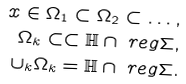<formula> <loc_0><loc_0><loc_500><loc_500>x \in \Omega _ { 1 } \subset \Omega _ { 2 } \subset \dots , \\ \Omega _ { k } \subset \subset \mathbb { H } \cap \ r e g \Sigma , \\ \cup _ { k } \Omega _ { k } = \mathbb { H } \cap \ r e g \Sigma .</formula> 